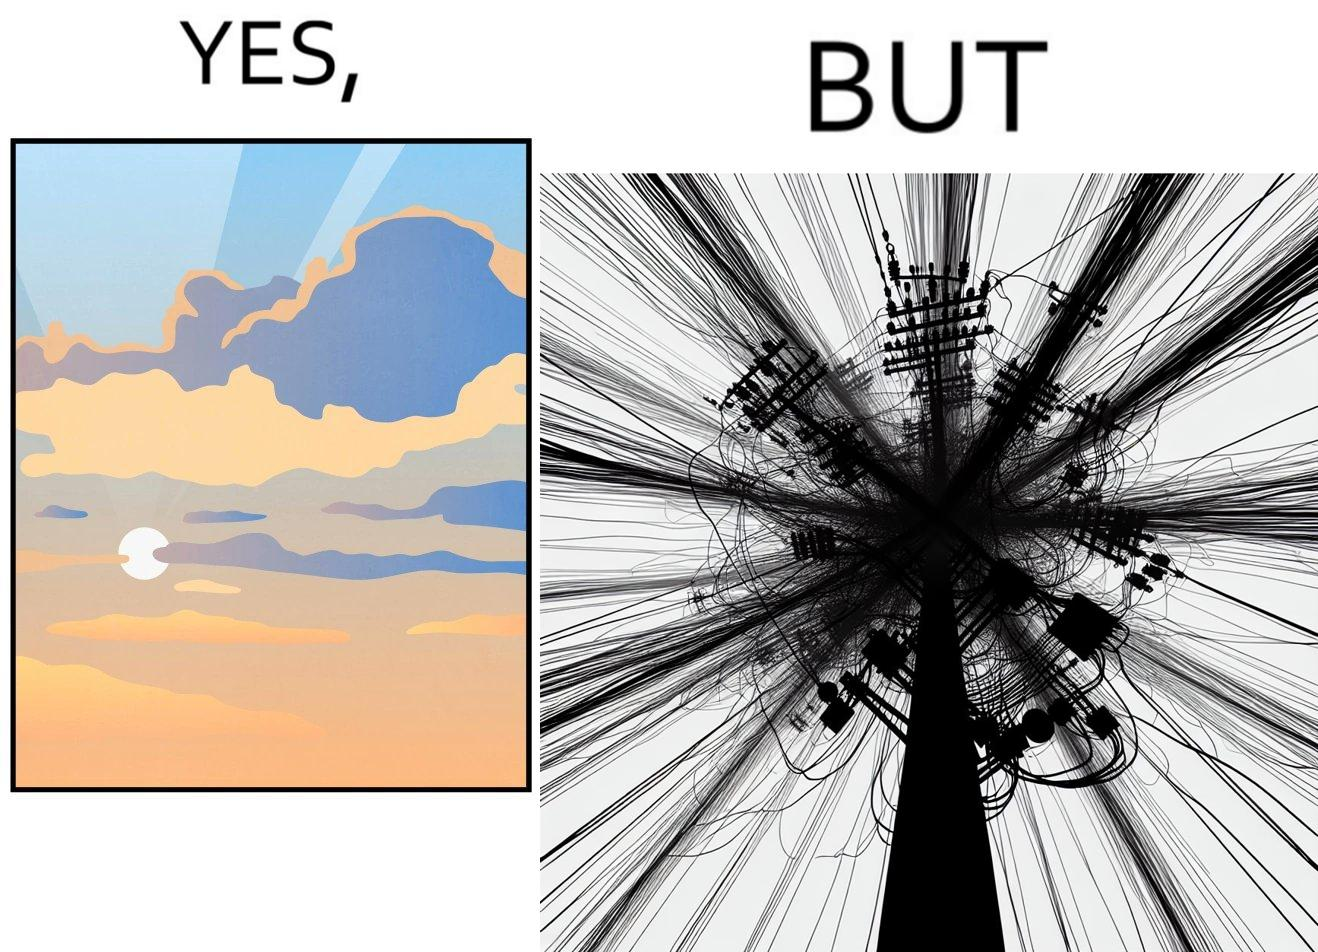What is shown in this image? The image is ironic, because in the first image clear sky is visible but in the second image the same view is getting blocked due to the electricity pole 